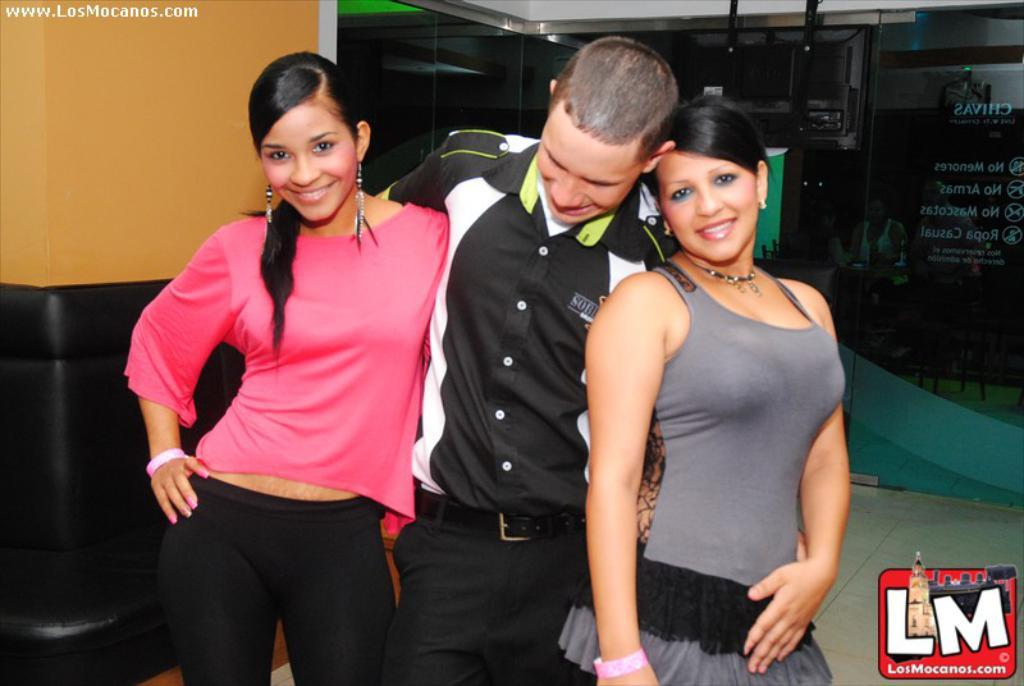How many people are in the foreground of the picture? There are three persons in the foreground of the picture. What expressions do the people have on their faces? The persons have smiles on their faces. Can you describe any architectural features visible in the picture? Yes, there is a glass door visible in the top right side of the picture. What type of trip is the dad planning for the family in the image? There is no dad or trip mentioned in the image; it only shows three people with smiles on their faces. 